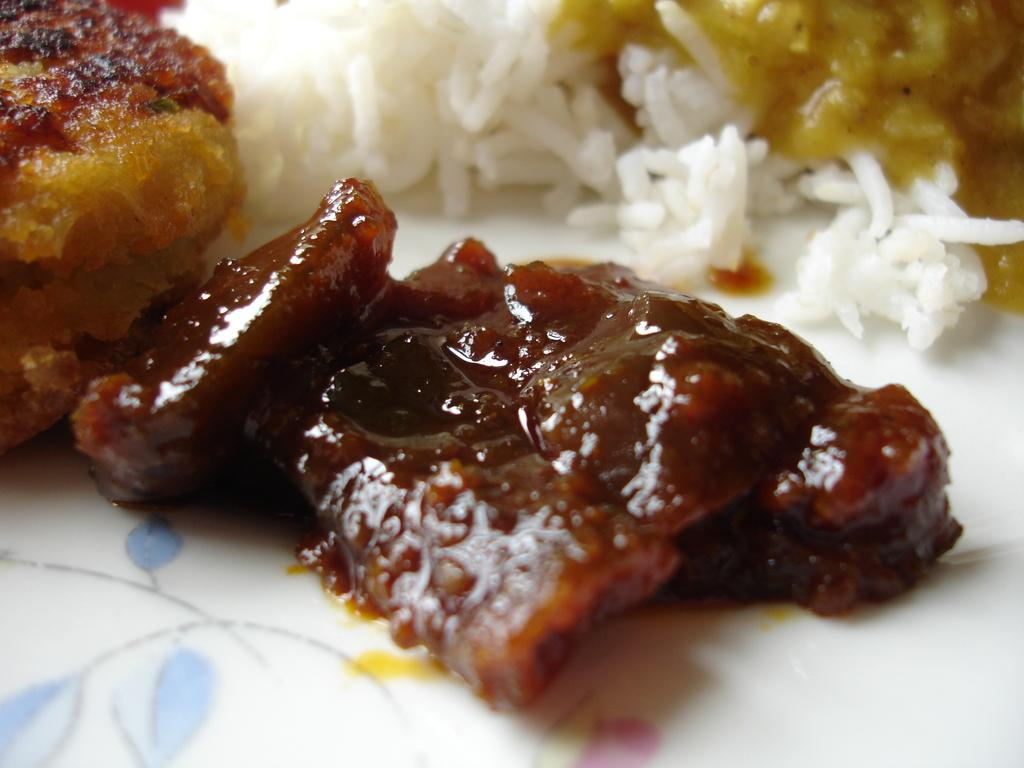What is on the plate that is visible in the image? There is a plate containing food in the image. What types of food can be seen on the plate? The food includes curry, rice, and dal. What is the route taken by the foot in the image? There is no foot present in the image, so it is not possible to determine a route. 